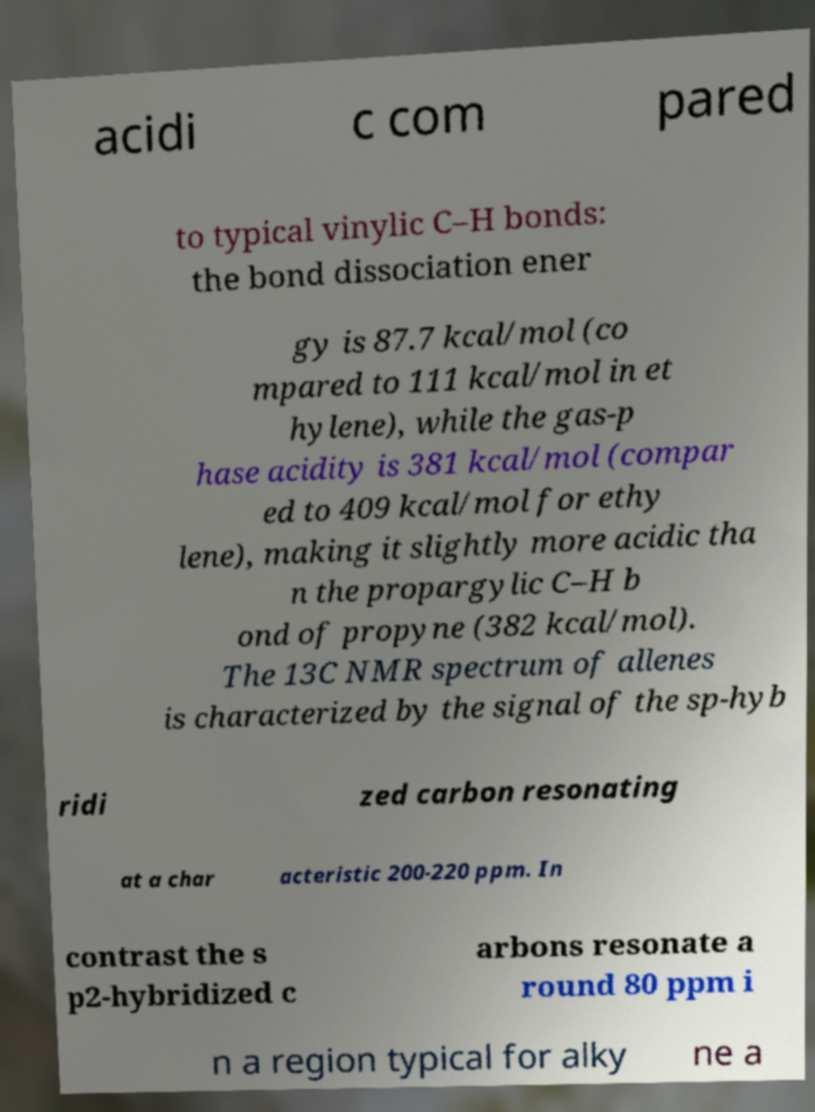Could you assist in decoding the text presented in this image and type it out clearly? acidi c com pared to typical vinylic C–H bonds: the bond dissociation ener gy is 87.7 kcal/mol (co mpared to 111 kcal/mol in et hylene), while the gas-p hase acidity is 381 kcal/mol (compar ed to 409 kcal/mol for ethy lene), making it slightly more acidic tha n the propargylic C–H b ond of propyne (382 kcal/mol). The 13C NMR spectrum of allenes is characterized by the signal of the sp-hyb ridi zed carbon resonating at a char acteristic 200-220 ppm. In contrast the s p2-hybridized c arbons resonate a round 80 ppm i n a region typical for alky ne a 